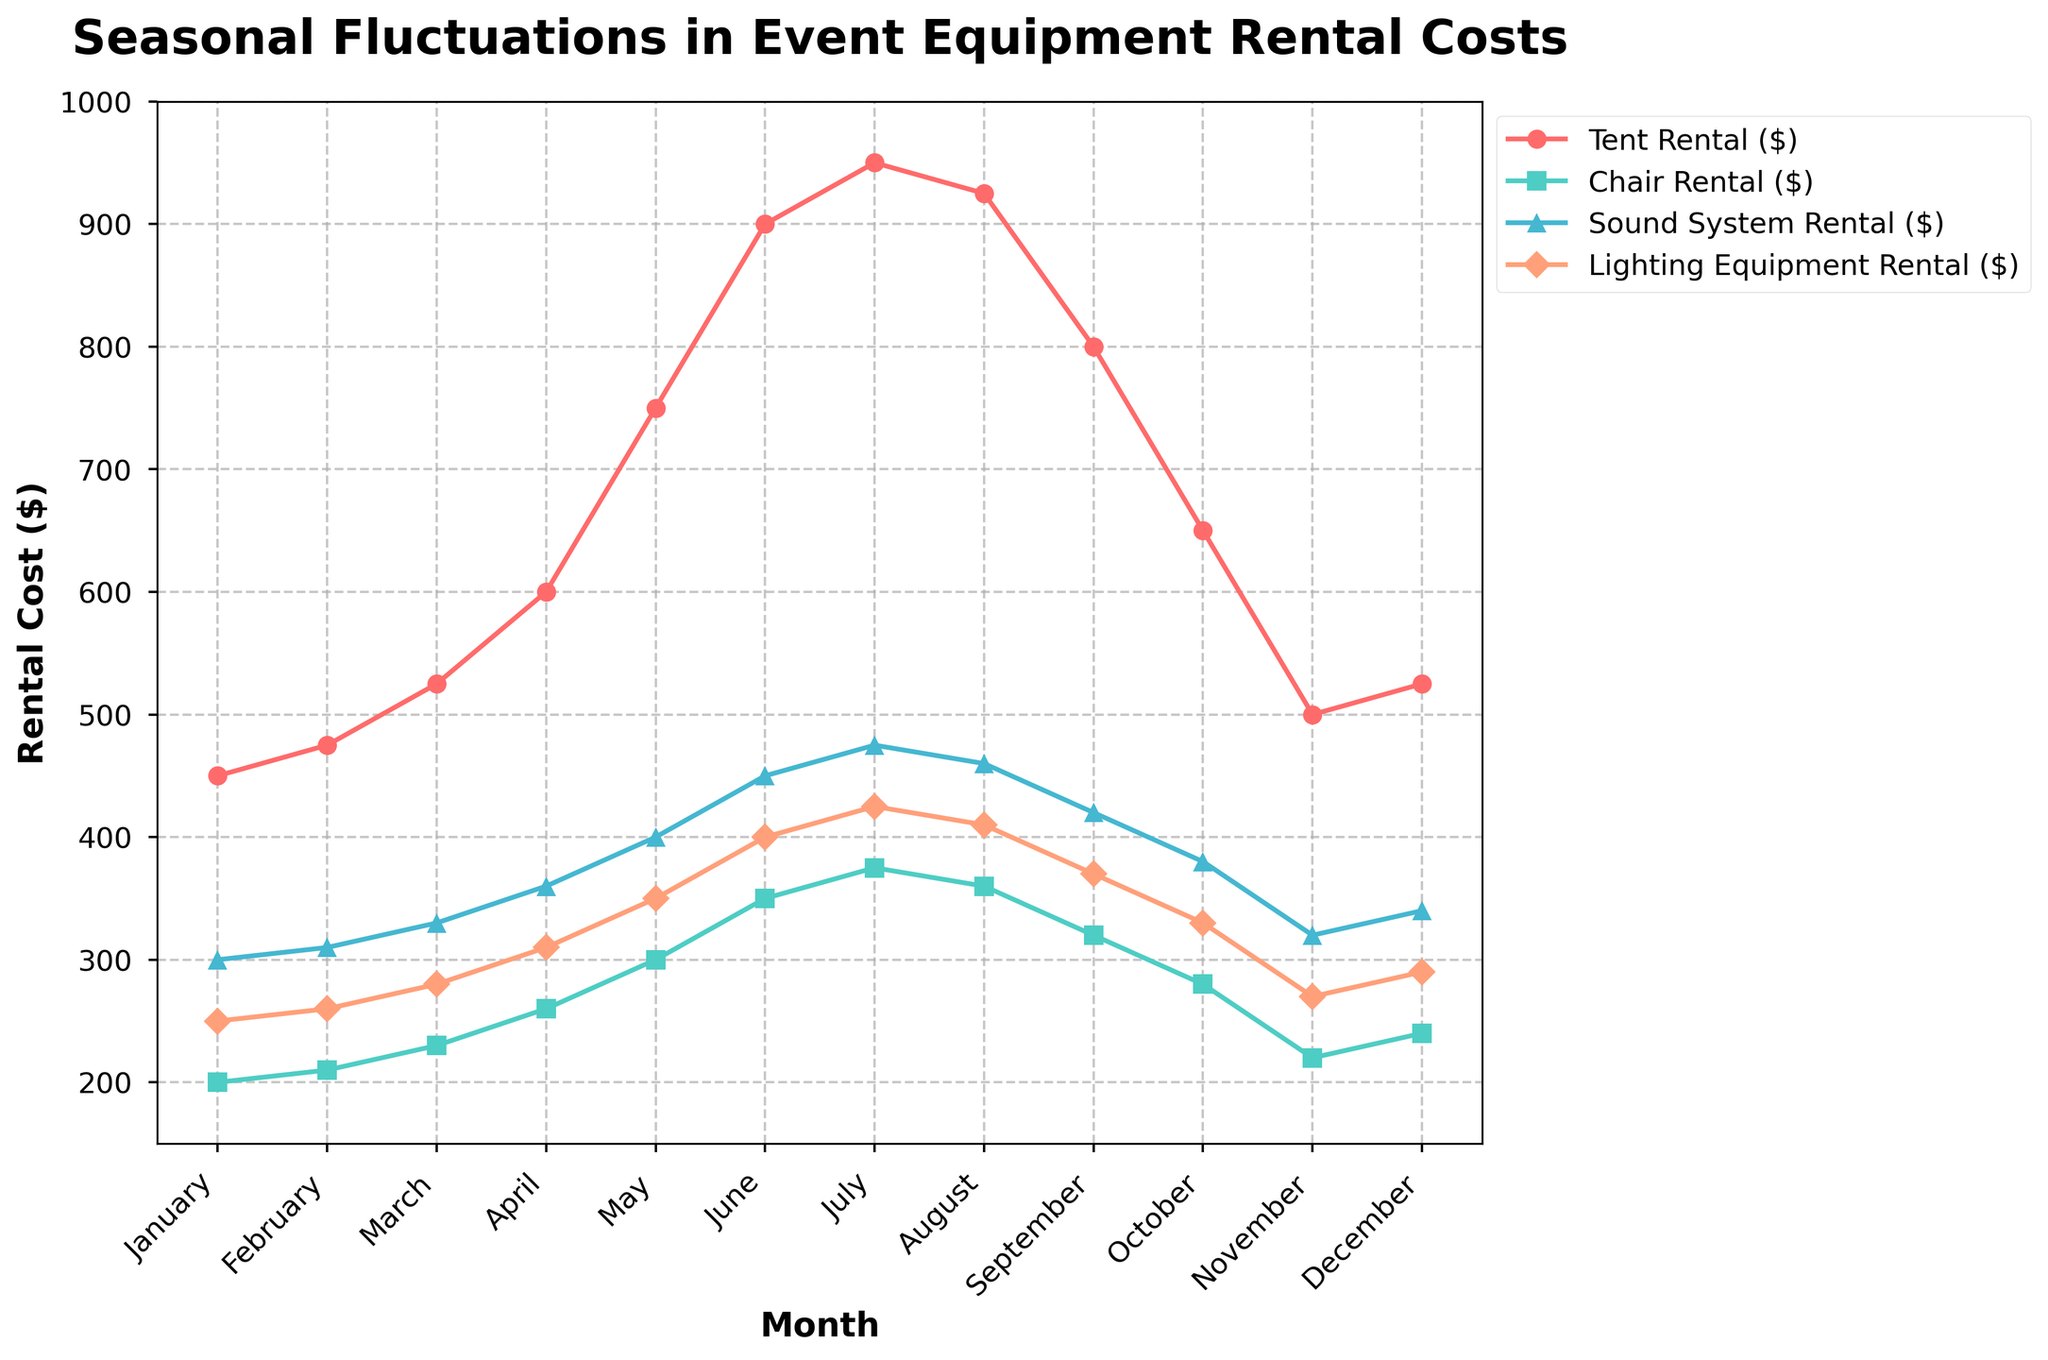What month has the highest tent rental cost? By examining the line plot representing tent rental costs over months, identify the peak point of the tent rental cost line.
Answer: July Which months show a decline in sound system rental costs? Look at the line representing sound system rental costs and identify any downward trends after each rise.
Answer: August to October What is the average cost of chair rental in the first quarter of the year? Sum the chair rental costs for January, February, and March, then divide by 3. (200 + 210 + 230) / 3
Answer: 213.33 In which month does lighting equipment rental reach its lowest cost? Find the point on the lighting equipment rental line which has the minimum value.
Answer: January By how much does the tent rental cost increase from January to June? Subtract the January tent rental cost from the June tent rental cost (900 - 450).
Answer: 450 Are there any months where chair rental costs are equal to lighting equipment rental costs? Check the line plot to spot any points where the lines for chair rental and lighting equipment rental intersect.
Answer: No What is the price difference between tent rental and sound system rental in May? Find the data points for tent rental and sound system rental in May and compute the difference (750 - 400).
Answer: 350 How do the chair rental costs in October compare to those in December? Compare the values of chair rental costs for October and December on the graph.
Answer: Higher in October Which rental costs have the smallest range throughout the year? Subtract the minimum value from the maximum value for each rental type and compare. Chair: (375 - 200), Sound System: (475 - 300), Lighting Equipment: (425 - 250), Tent: (950 - 450). Chair Rental has the smallest range of 175.
Answer: Chair Rental What is the total increase in sound system rental cost from March to July? Calculate the difference between the sound system rental costs in March and July (475 - 330).
Answer: 145 